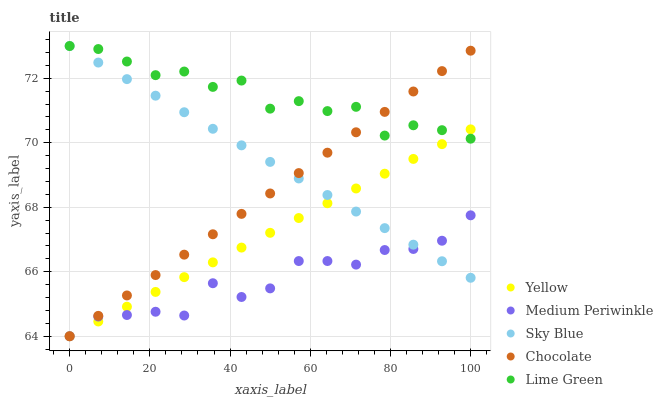Does Medium Periwinkle have the minimum area under the curve?
Answer yes or no. Yes. Does Lime Green have the maximum area under the curve?
Answer yes or no. Yes. Does Sky Blue have the minimum area under the curve?
Answer yes or no. No. Does Sky Blue have the maximum area under the curve?
Answer yes or no. No. Is Sky Blue the smoothest?
Answer yes or no. Yes. Is Lime Green the roughest?
Answer yes or no. Yes. Is Medium Periwinkle the smoothest?
Answer yes or no. No. Is Medium Periwinkle the roughest?
Answer yes or no. No. Does Medium Periwinkle have the lowest value?
Answer yes or no. Yes. Does Sky Blue have the lowest value?
Answer yes or no. No. Does Sky Blue have the highest value?
Answer yes or no. Yes. Does Medium Periwinkle have the highest value?
Answer yes or no. No. Is Medium Periwinkle less than Lime Green?
Answer yes or no. Yes. Is Lime Green greater than Medium Periwinkle?
Answer yes or no. Yes. Does Sky Blue intersect Yellow?
Answer yes or no. Yes. Is Sky Blue less than Yellow?
Answer yes or no. No. Is Sky Blue greater than Yellow?
Answer yes or no. No. Does Medium Periwinkle intersect Lime Green?
Answer yes or no. No. 